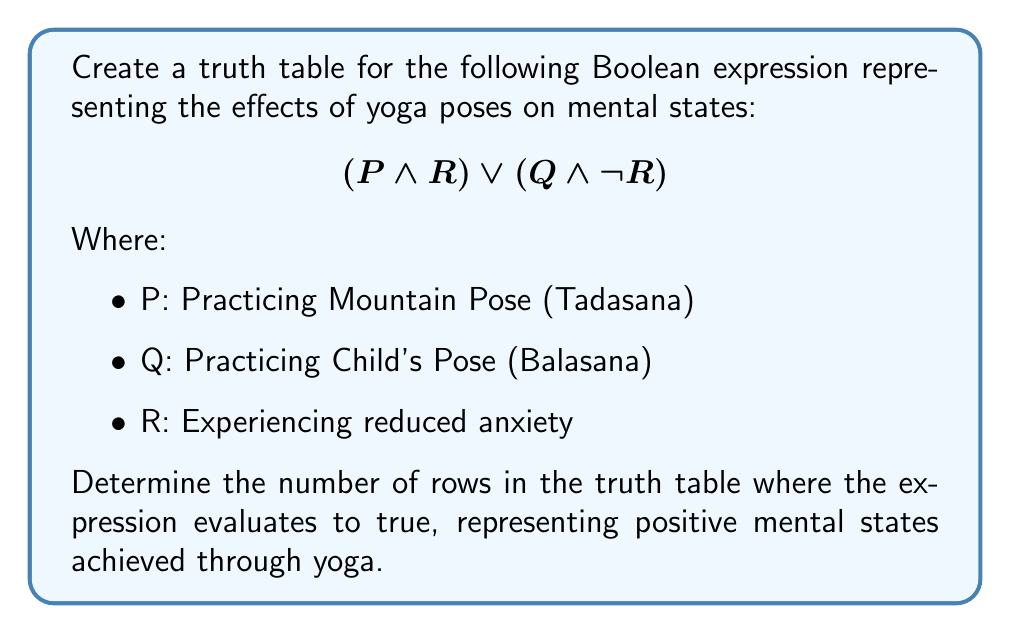What is the answer to this math problem? To solve this problem, we'll follow these steps:

1. Identify the variables: P, Q, and R
2. Create a truth table with 8 rows (2^3 variables)
3. Evaluate the sub-expressions: $(P \land R)$ and $(Q \land \neg R)$
4. Evaluate the entire expression: $(P \land R) \lor (Q \land \neg R)$
5. Count the number of true outcomes

Step 1: Variables are P, Q, and R

Step 2: Truth table with 8 rows:

$$\begin{array}{|c|c|c|c|c|c|}
\hline
P & Q & R & (P \land R) & (Q \land \neg R) & (P \land R) \lor (Q \land \neg R) \\
\hline
0 & 0 & 0 & 0 & 0 & 0 \\
0 & 0 & 1 & 0 & 0 & 0 \\
0 & 1 & 0 & 0 & 1 & 1 \\
0 & 1 & 1 & 0 & 0 & 0 \\
1 & 0 & 0 & 0 & 0 & 0 \\
1 & 0 & 1 & 1 & 0 & 1 \\
1 & 1 & 0 & 0 & 1 & 1 \\
1 & 1 & 1 & 1 & 0 & 1 \\
\hline
\end{array}$$

Step 3 & 4: Evaluation of sub-expressions and the entire expression is shown in the truth table above.

Step 5: Count the number of true outcomes in the last column.

There are 4 rows where the expression evaluates to true (1).
Answer: 4 